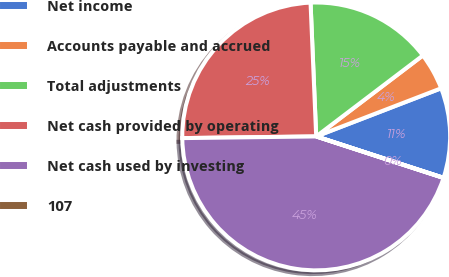<chart> <loc_0><loc_0><loc_500><loc_500><pie_chart><fcel>Net income<fcel>Accounts payable and accrued<fcel>Total adjustments<fcel>Net cash provided by operating<fcel>Net cash used by investing<fcel>107<nl><fcel>10.86%<fcel>4.48%<fcel>15.34%<fcel>24.53%<fcel>44.79%<fcel>0.01%<nl></chart> 